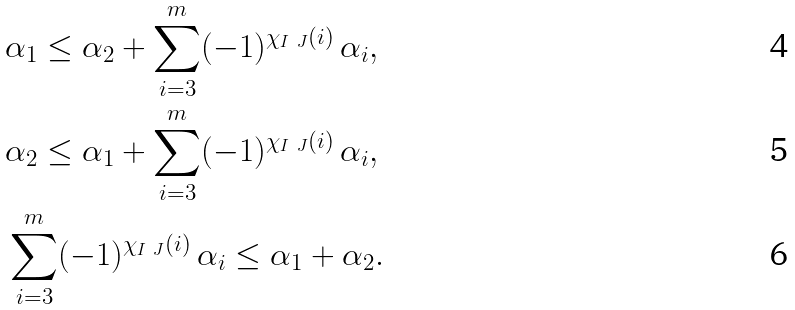<formula> <loc_0><loc_0><loc_500><loc_500>& \alpha _ { 1 } \leq \alpha _ { 2 } + \sum _ { i = 3 } ^ { m } ( - 1 ) ^ { \chi _ { I \ J } ( i ) } \, \alpha _ { i } , \\ & \alpha _ { 2 } \leq \alpha _ { 1 } + \sum _ { i = 3 } ^ { m } ( - 1 ) ^ { \chi _ { I \ J } ( i ) } \, \alpha _ { i } , \\ & \sum _ { i = 3 } ^ { m } ( - 1 ) ^ { \chi _ { I \ J } ( i ) } \, \alpha _ { i } \leq \alpha _ { 1 } + \alpha _ { 2 } .</formula> 